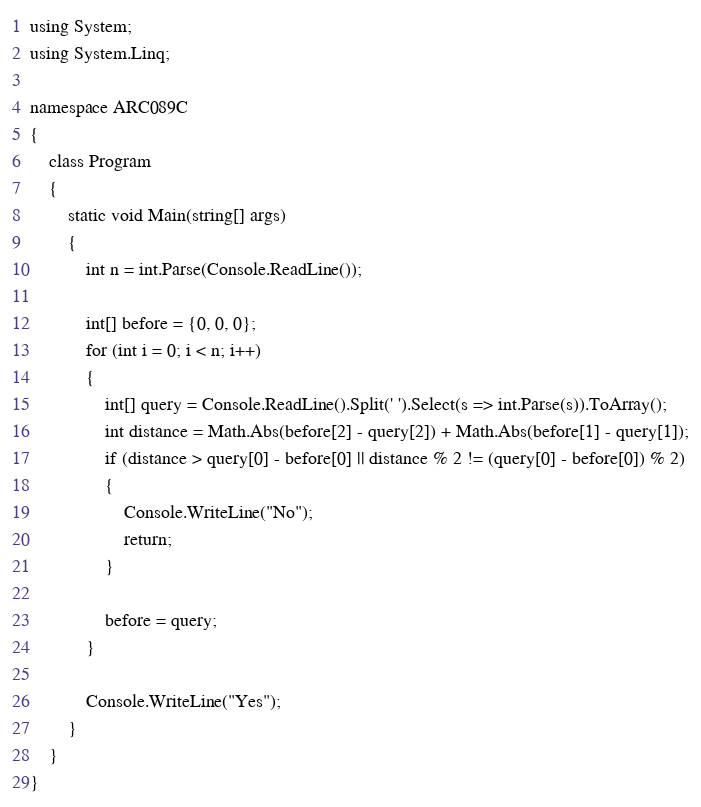Convert code to text. <code><loc_0><loc_0><loc_500><loc_500><_C#_>using System;
using System.Linq;

namespace ARC089C
{
    class Program
    {
        static void Main(string[] args)
        {
            int n = int.Parse(Console.ReadLine());

            int[] before = {0, 0, 0};
            for (int i = 0; i < n; i++)
            {
                int[] query = Console.ReadLine().Split(' ').Select(s => int.Parse(s)).ToArray();
                int distance = Math.Abs(before[2] - query[2]) + Math.Abs(before[1] - query[1]);
                if (distance > query[0] - before[0] || distance % 2 != (query[0] - before[0]) % 2)
                {
                    Console.WriteLine("No");
                    return;
                }

                before = query;
            }

            Console.WriteLine("Yes");
        }
    }
}</code> 